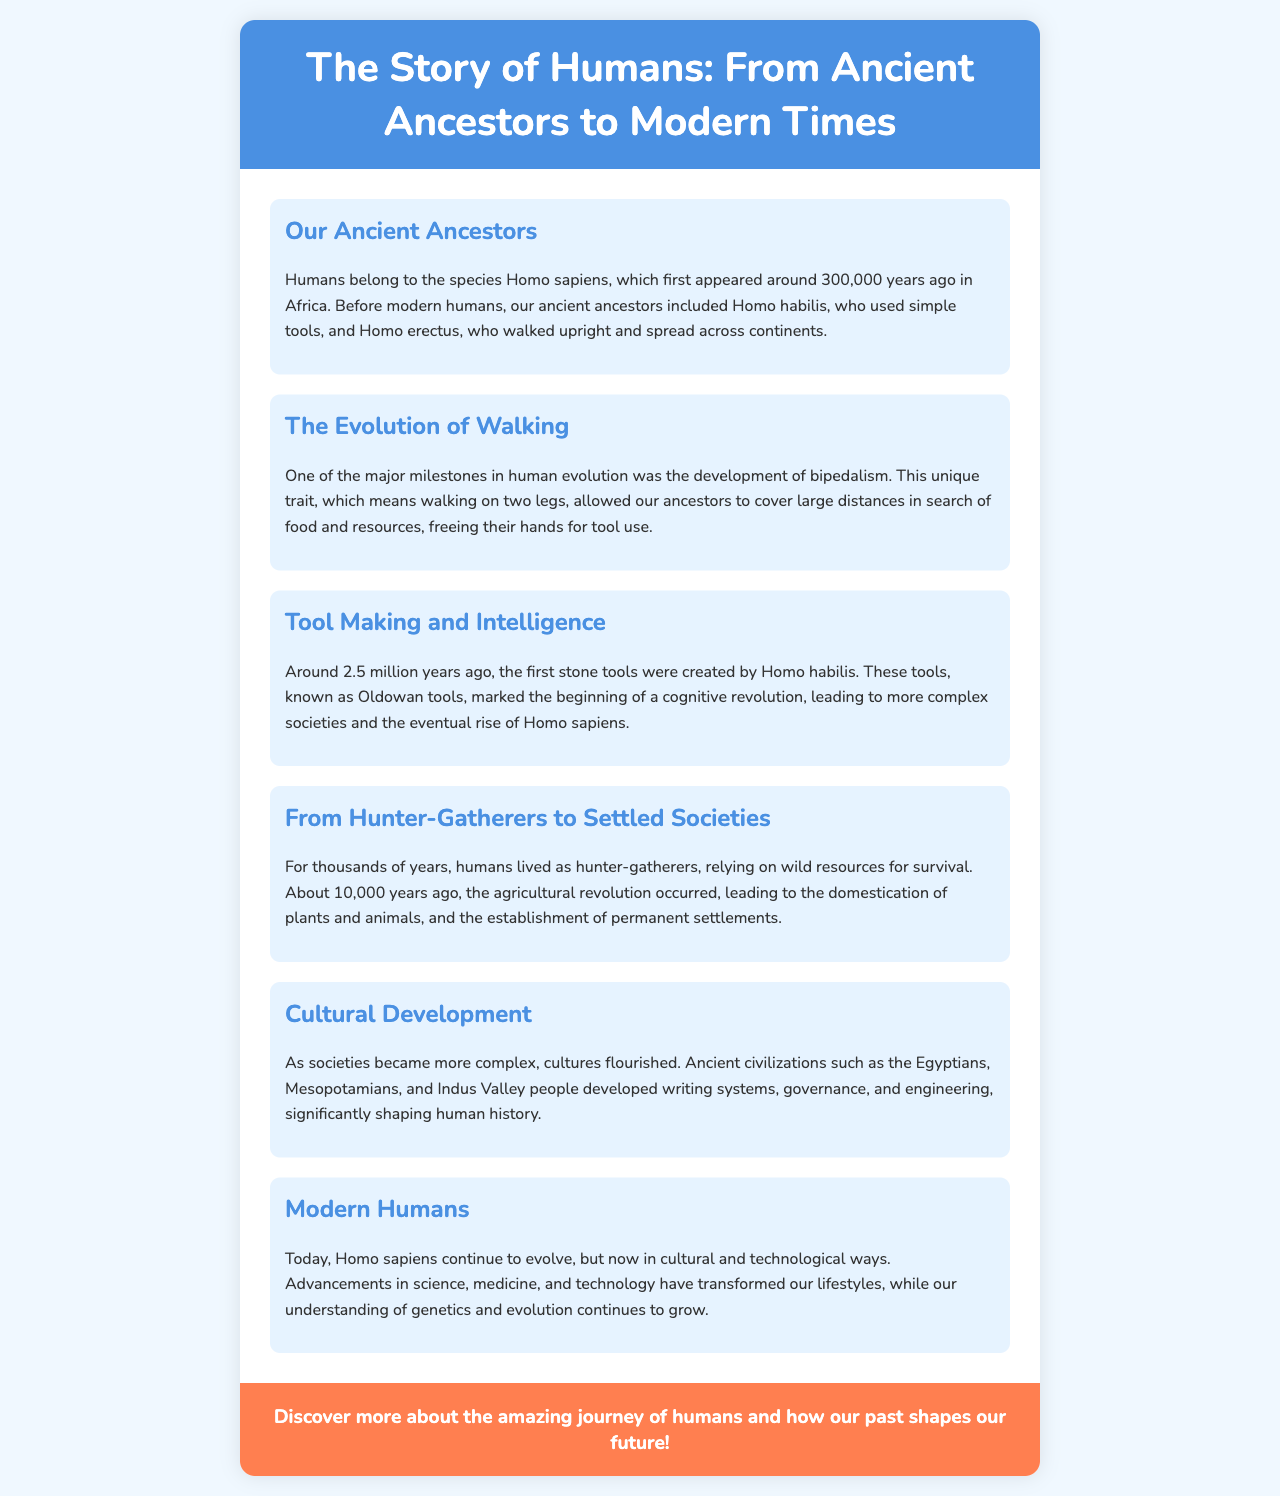what species do modern humans belong to? The document states that modern humans belong to the species Homo sapiens.
Answer: Homo sapiens when did Homo sapiens first appear? The brochure mentions that Homo sapiens first appeared around 300,000 years ago.
Answer: 300,000 years ago what major milestone allowed our ancestors to cover large distances? The document describes bipedalism as a major milestone that allowed our ancestors to cover large distances.
Answer: bipedalism how long did humans live as hunter-gatherers? According to the brochure, humans lived as hunter-gatherers for thousands of years.
Answer: thousands of years what was established around 10,000 years ago? The document notes that the agricultural revolution and the establishment of permanent settlements occurred around 10,000 years ago.
Answer: agricultural revolution which ancient civilizations are mentioned? The brochure lists ancient civilizations such as the Egyptians, Mesopotamians, and Indus Valley people.
Answer: Egyptians, Mesopotamians, Indus Valley what kind of development have modern humans experienced? The document states that modern humans continue to evolve culturally and technologically.
Answer: culturally and technologically what type of tools were created by Homo habilis? The brochure states that Homo habilis created stone tools known as Oldowan tools.
Answer: Oldowan tools what is featured in the call to action? The document invites readers to discover more about human journeys and their future implications.
Answer: amazing journey of humans and how our past shapes our future 